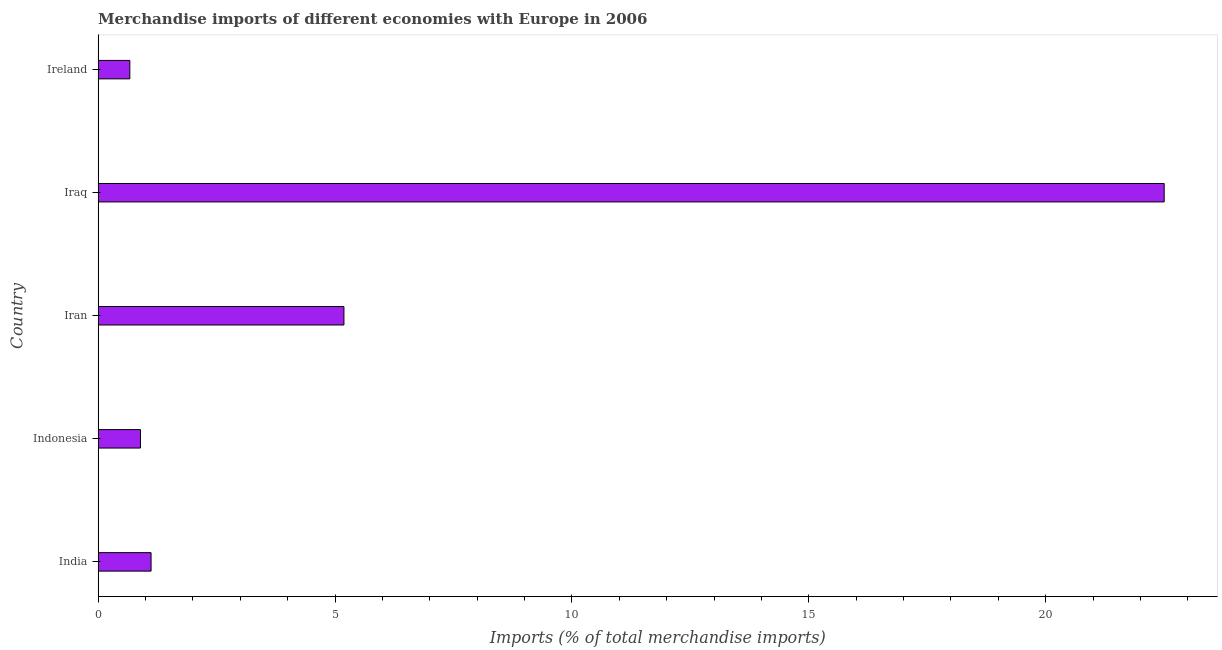Does the graph contain any zero values?
Offer a very short reply. No. What is the title of the graph?
Offer a terse response. Merchandise imports of different economies with Europe in 2006. What is the label or title of the X-axis?
Offer a very short reply. Imports (% of total merchandise imports). What is the merchandise imports in Iraq?
Offer a very short reply. 22.5. Across all countries, what is the maximum merchandise imports?
Your answer should be very brief. 22.5. Across all countries, what is the minimum merchandise imports?
Give a very brief answer. 0.67. In which country was the merchandise imports maximum?
Your response must be concise. Iraq. In which country was the merchandise imports minimum?
Offer a very short reply. Ireland. What is the sum of the merchandise imports?
Give a very brief answer. 30.37. What is the difference between the merchandise imports in India and Indonesia?
Keep it short and to the point. 0.22. What is the average merchandise imports per country?
Give a very brief answer. 6.07. What is the median merchandise imports?
Provide a short and direct response. 1.12. What is the ratio of the merchandise imports in Iraq to that in Ireland?
Offer a terse response. 33.62. Is the merchandise imports in Iran less than that in Ireland?
Offer a terse response. No. What is the difference between the highest and the second highest merchandise imports?
Your answer should be compact. 17.31. What is the difference between the highest and the lowest merchandise imports?
Ensure brevity in your answer.  21.83. In how many countries, is the merchandise imports greater than the average merchandise imports taken over all countries?
Give a very brief answer. 1. How many bars are there?
Your answer should be compact. 5. What is the difference between two consecutive major ticks on the X-axis?
Provide a succinct answer. 5. Are the values on the major ticks of X-axis written in scientific E-notation?
Your answer should be very brief. No. What is the Imports (% of total merchandise imports) of India?
Provide a short and direct response. 1.12. What is the Imports (% of total merchandise imports) in Indonesia?
Provide a succinct answer. 0.89. What is the Imports (% of total merchandise imports) of Iran?
Offer a terse response. 5.19. What is the Imports (% of total merchandise imports) of Iraq?
Offer a very short reply. 22.5. What is the Imports (% of total merchandise imports) in Ireland?
Provide a short and direct response. 0.67. What is the difference between the Imports (% of total merchandise imports) in India and Indonesia?
Offer a very short reply. 0.22. What is the difference between the Imports (% of total merchandise imports) in India and Iran?
Ensure brevity in your answer.  -4.07. What is the difference between the Imports (% of total merchandise imports) in India and Iraq?
Your response must be concise. -21.38. What is the difference between the Imports (% of total merchandise imports) in India and Ireland?
Ensure brevity in your answer.  0.45. What is the difference between the Imports (% of total merchandise imports) in Indonesia and Iran?
Your answer should be very brief. -4.29. What is the difference between the Imports (% of total merchandise imports) in Indonesia and Iraq?
Your response must be concise. -21.61. What is the difference between the Imports (% of total merchandise imports) in Indonesia and Ireland?
Provide a short and direct response. 0.22. What is the difference between the Imports (% of total merchandise imports) in Iran and Iraq?
Provide a short and direct response. -17.31. What is the difference between the Imports (% of total merchandise imports) in Iran and Ireland?
Give a very brief answer. 4.52. What is the difference between the Imports (% of total merchandise imports) in Iraq and Ireland?
Give a very brief answer. 21.83. What is the ratio of the Imports (% of total merchandise imports) in India to that in Iran?
Provide a succinct answer. 0.21. What is the ratio of the Imports (% of total merchandise imports) in India to that in Iraq?
Your answer should be very brief. 0.05. What is the ratio of the Imports (% of total merchandise imports) in India to that in Ireland?
Ensure brevity in your answer.  1.67. What is the ratio of the Imports (% of total merchandise imports) in Indonesia to that in Iran?
Ensure brevity in your answer.  0.17. What is the ratio of the Imports (% of total merchandise imports) in Indonesia to that in Ireland?
Your answer should be compact. 1.34. What is the ratio of the Imports (% of total merchandise imports) in Iran to that in Iraq?
Offer a terse response. 0.23. What is the ratio of the Imports (% of total merchandise imports) in Iran to that in Ireland?
Offer a very short reply. 7.75. What is the ratio of the Imports (% of total merchandise imports) in Iraq to that in Ireland?
Offer a terse response. 33.62. 